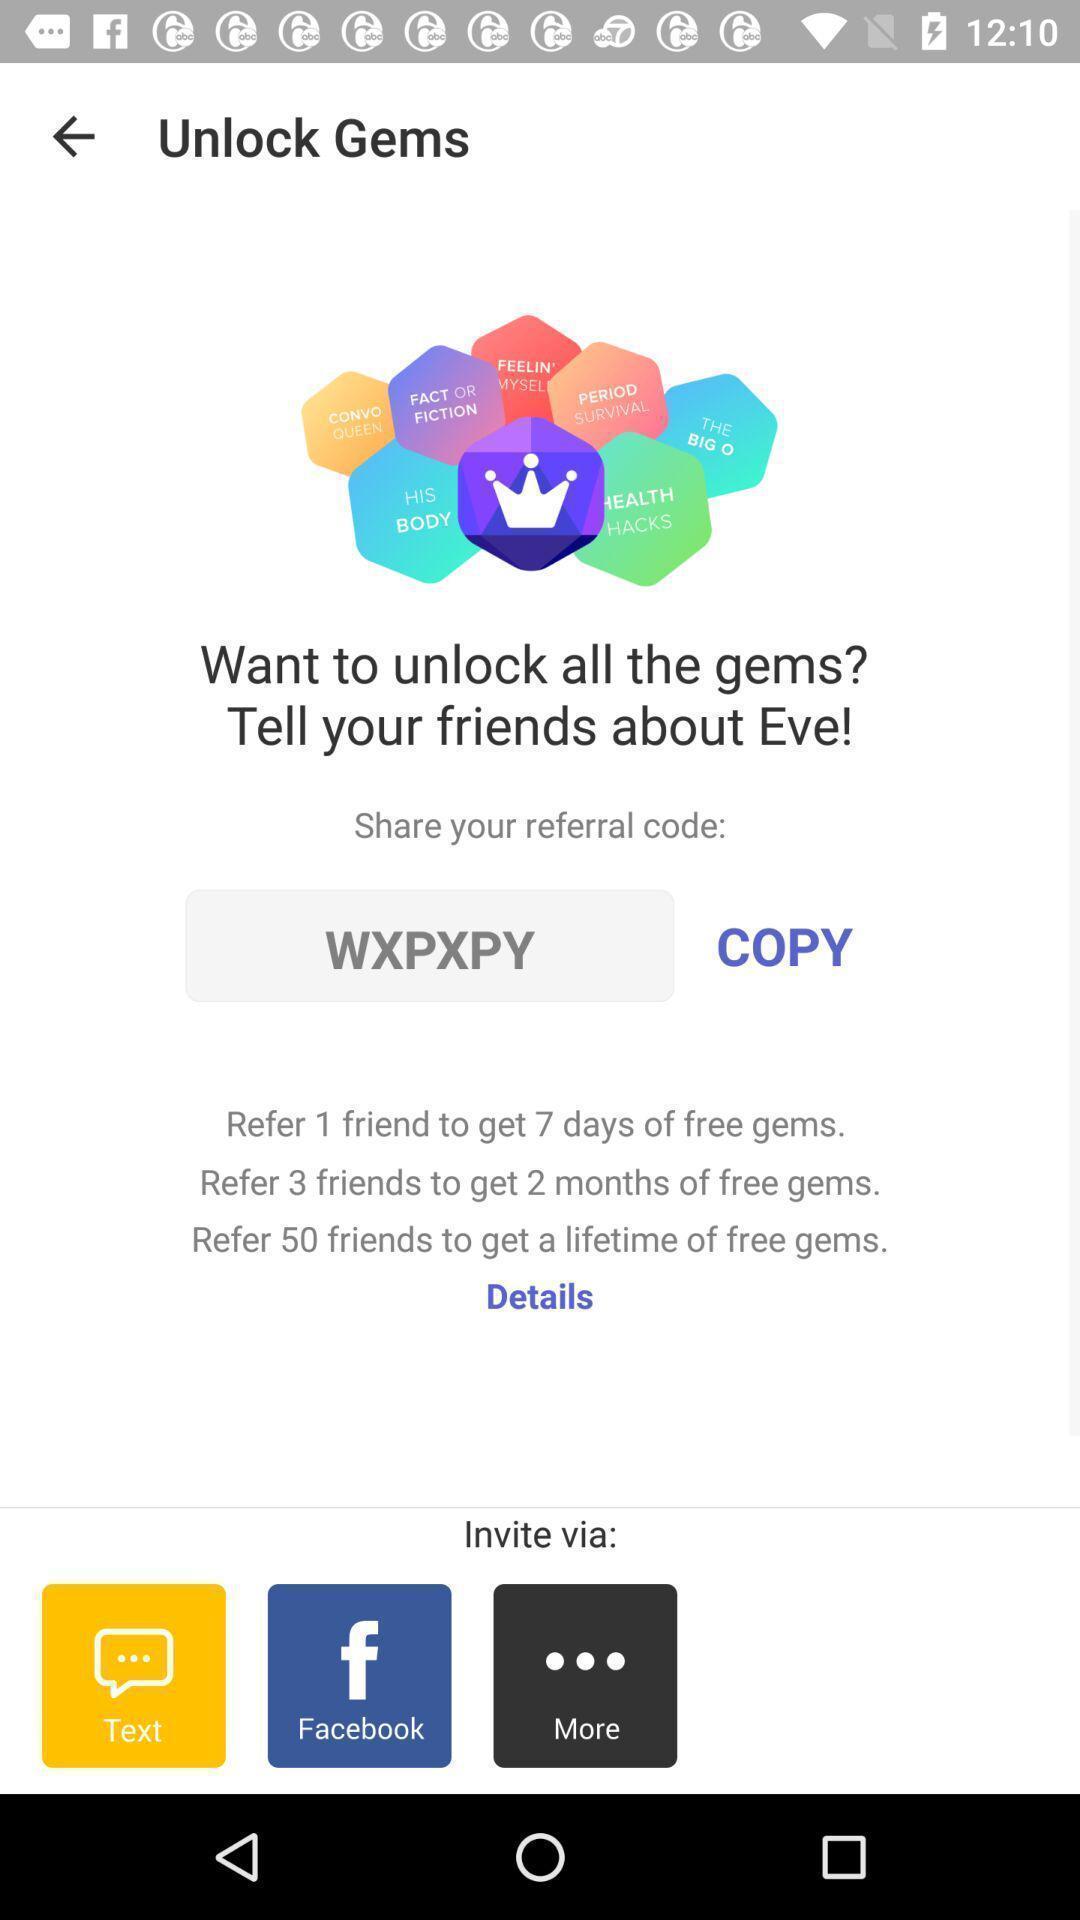What is the overall content of this screenshot? Page with invite via options. 